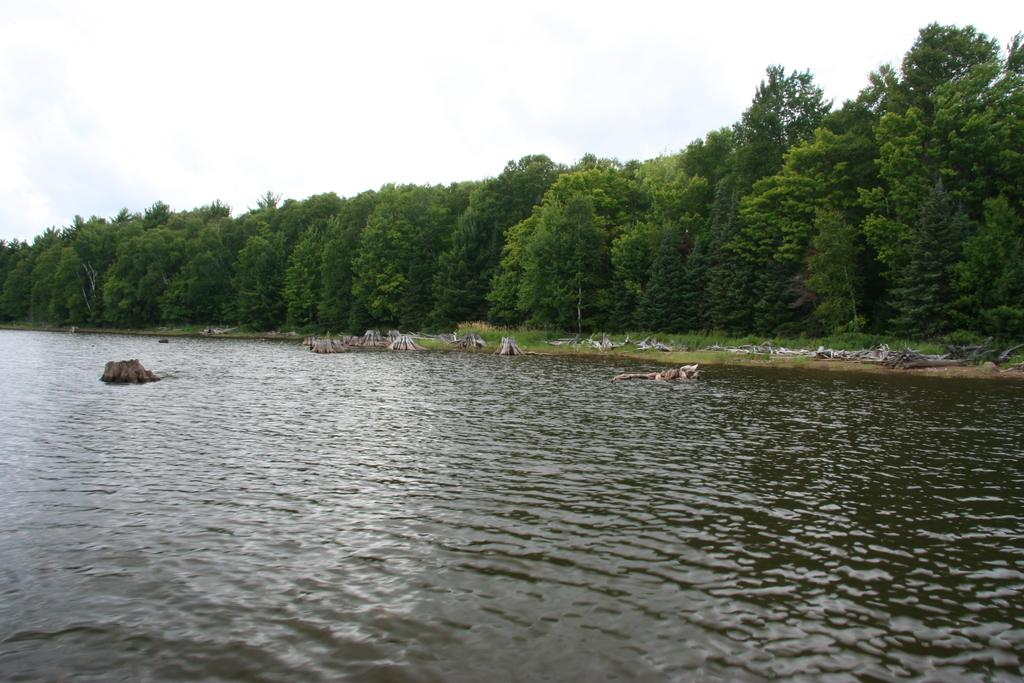What type of vegetation is present in the image? There are many trees, plants, and grass in the image. What else can be seen in the image besides vegetation? There are objects and water at the bottom of the image. What is visible at the top of the image? The sky is visible at the top of the image. How many clovers can be seen growing in the image? There is no mention of clovers in the image, so it is impossible to determine their presence or quantity. 